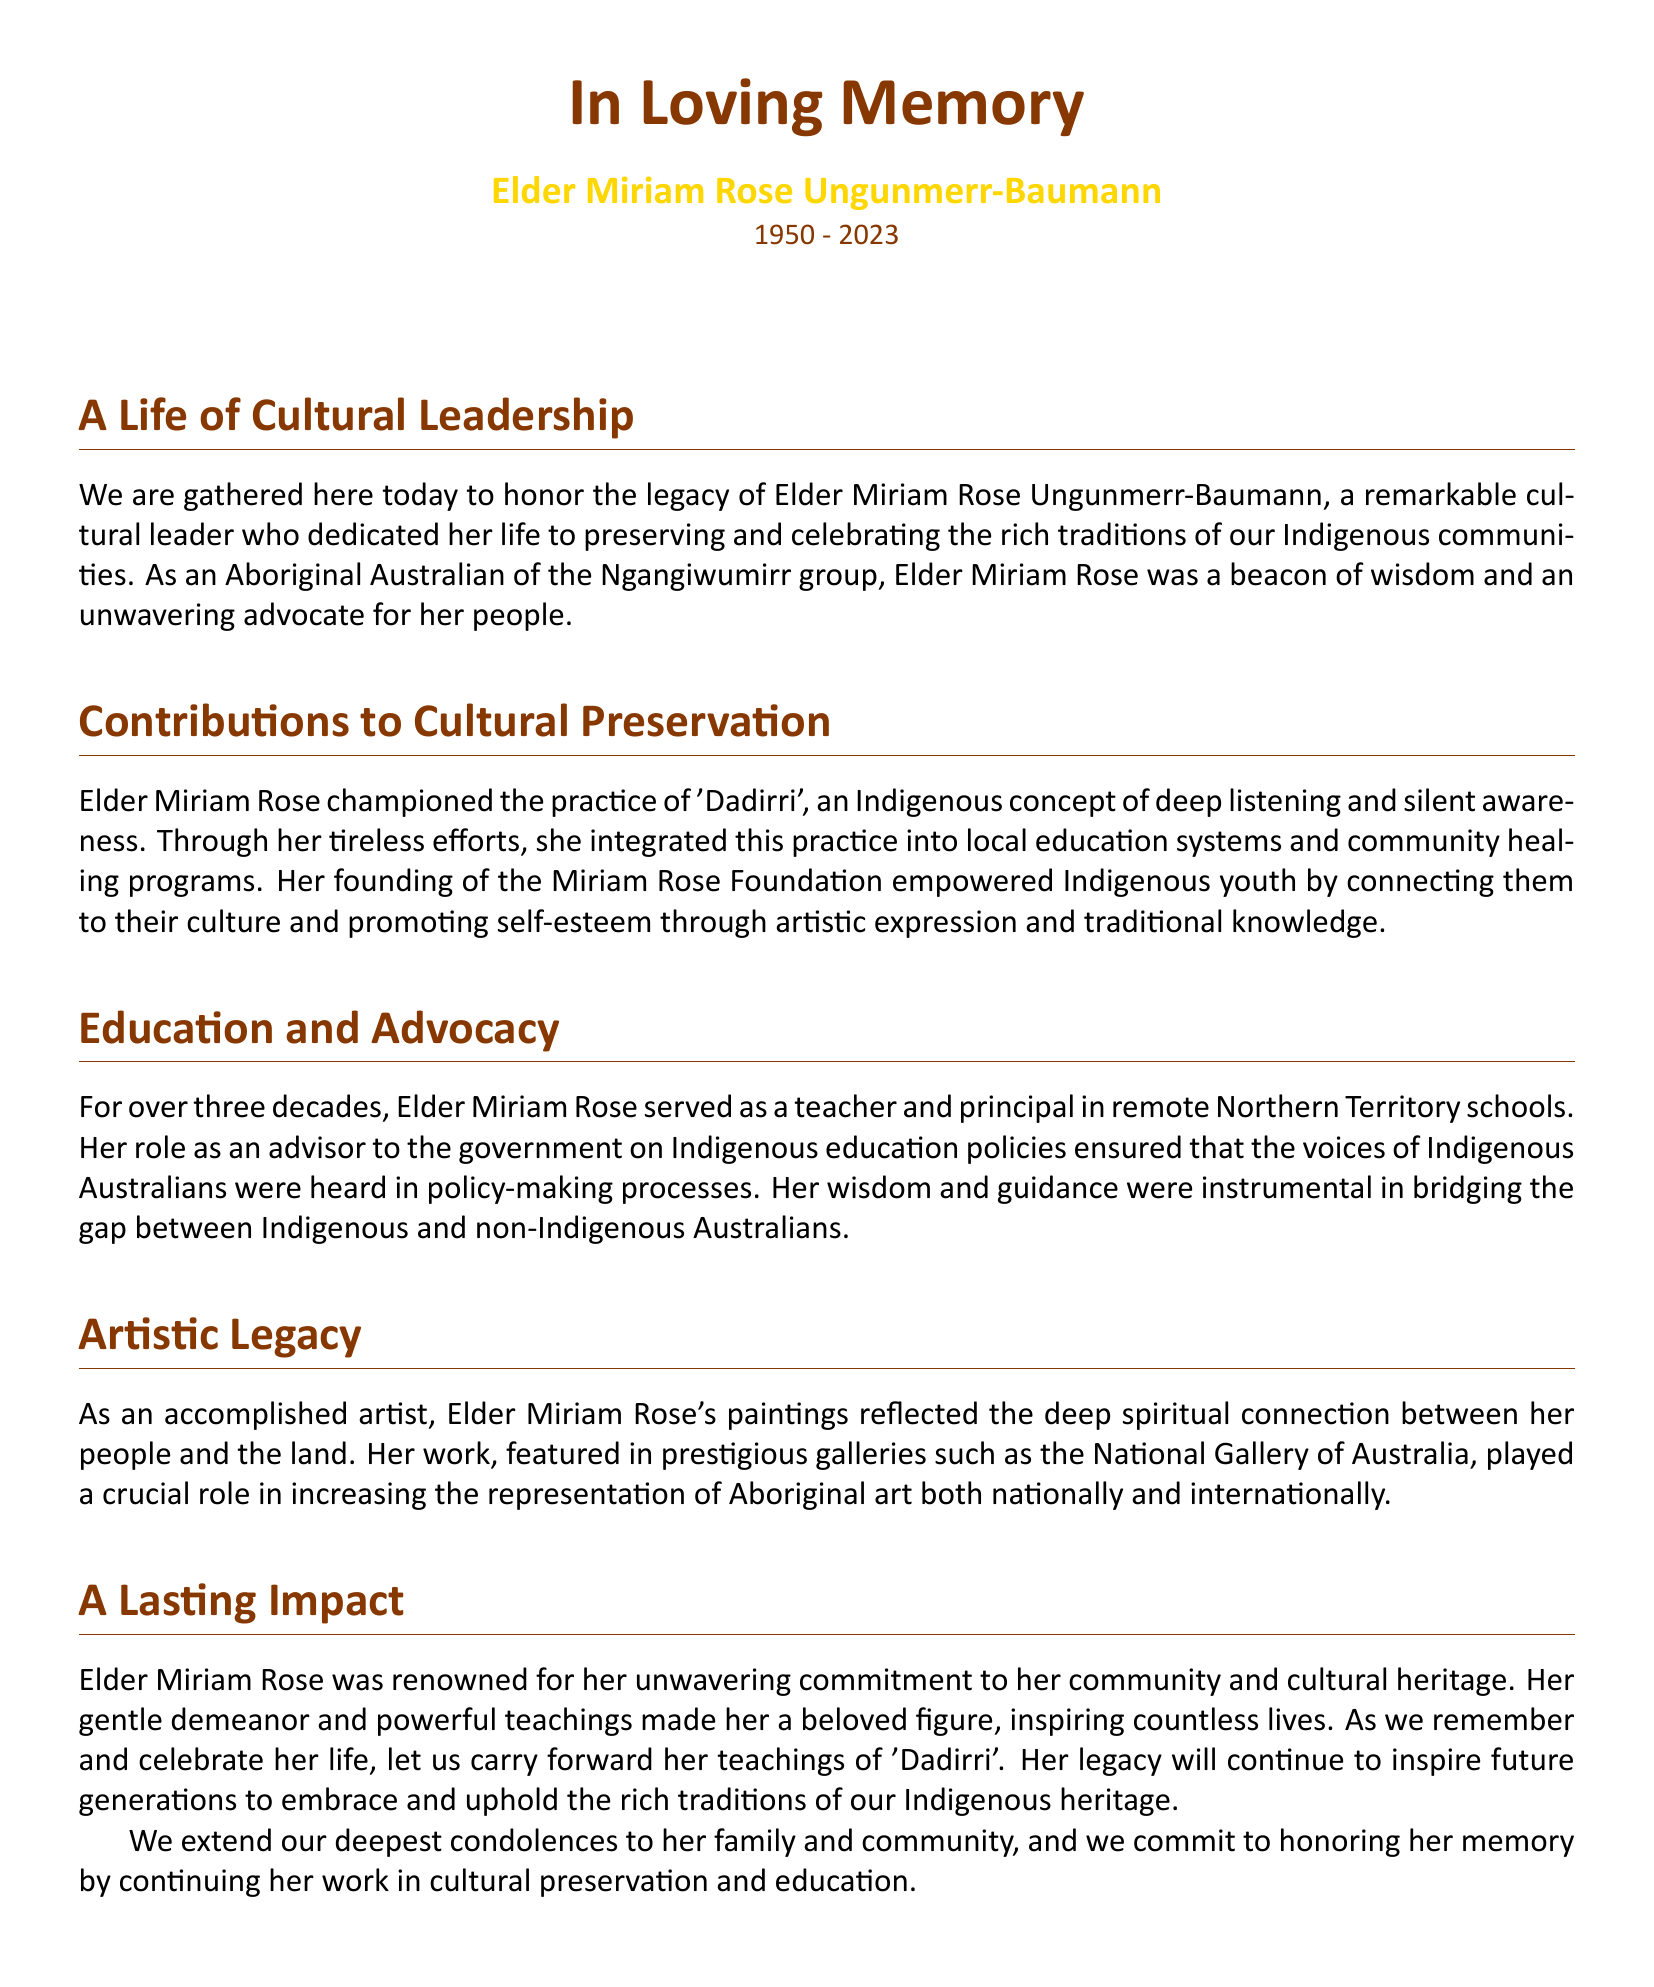What is Elder Miriam Rose's full name? The document states the full name of the cultural leader is Elder Miriam Rose Ungunmerr-Baumann.
Answer: Elder Miriam Rose Ungunmerr-Baumann What year was Elder Miriam Rose born? The document mentions her birth year as 1950.
Answer: 1950 What Indigenous group does Elder Miriam Rose belong to? The document identifies her as an Aboriginal Australian of the Ngangiwumirr group.
Answer: Ngangiwumirr What concept did Elder Miriam Rose champion? The document notes that she championed the practice of 'Dadirri'.
Answer: Dadirri How long did Elder Miriam Rose serve as a teacher and principal? The document mentions she served for over three decades.
Answer: Over three decades Which foundation did Elder Miriam Rose found? The document refers to the foundation she established as the Miriam Rose Foundation.
Answer: Miriam Rose Foundation What is the significance of Elder Miriam Rose's artistic work? The document states her work played a crucial role in increasing the representation of Aboriginal art.
Answer: Representation of Aboriginal art What was Elder Miriam Rose known for within her community? The document describes her commitment to cultural heritage and community.
Answer: Commitment to cultural heritage What teachings of Elder Miriam Rose should be carried forward? The document emphasizes the teachings of 'Dadirri' should be upheld.
Answer: Dadirri 